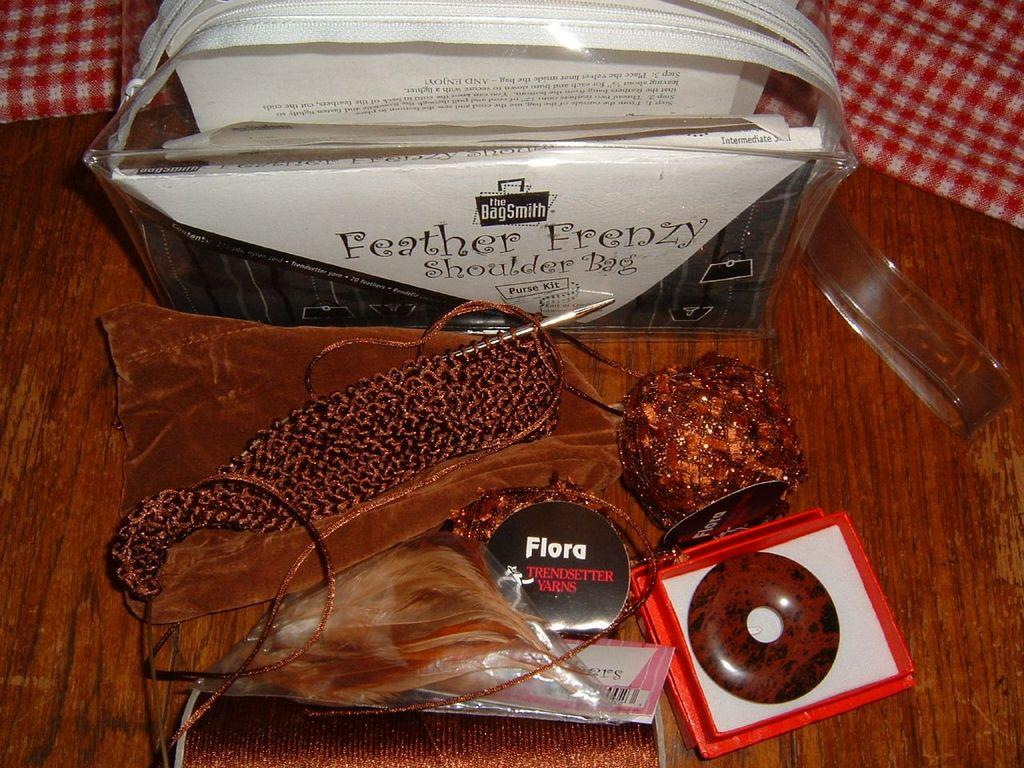What is located at the bottom of the image? There is a table at the bottom of the image. What can be found on the table in the image? There are products on the table. What type of bridge can be seen in the image? There is no bridge present in the image. What season is depicted in the image? The image does not depict a specific season, so it cannot be determined from the image alone. 